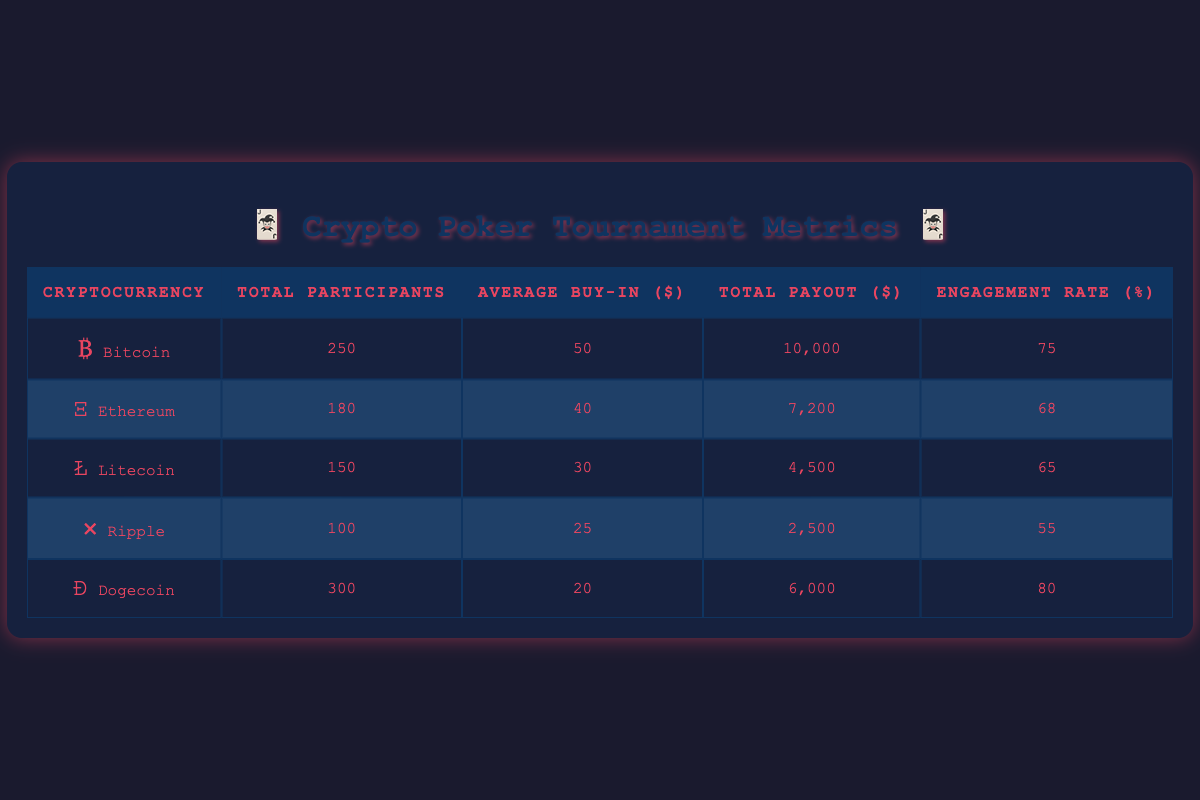What is the total payout for Dogecoin tournaments? In the table, the row for Dogecoin indicates that the total payout is $6000. This value is retrieved directly from the table without the need for calculations.
Answer: 6000 How many participants were there in Litecoin tournaments? The corresponding row for Litecoin indicates that there were 150 participants. This value is also directly retrieved from the table.
Answer: 150 Which cryptocurrency had the highest engagement rate? By examining the "Engagement Rate (%)" column, we find that Dogecoin has the highest engagement rate of 80%. This is the maximum value in that column.
Answer: Dogecoin What is the average buy-in for all tournaments combined? First, we sum the Average Buy-in amounts: (50 + 40 + 30 + 25 + 20) = 165. Then, we divide by the number of cryptocurrencies (5) to find the average: 165 / 5 = 33.
Answer: 33 Is the engagement rate for Ethereum greater than or equal to 70%? Looking at the engagement rate for Ethereum, which is 68%, we determine that it is not greater than or equal to 70%. Therefore, the answer is no.
Answer: No How much total payout was made across all poker tournaments? We sum up the total payouts for each cryptocurrency: (10000 + 7200 + 4500 + 2500 + 6000) = 32000. This gives us the total payout across all tournaments.
Answer: 32000 What is the difference in total participants between Bitcoin and Ripple tournaments? Bitcoin had 250 participants and Ripple had 100 participants. The difference is calculated as 250 - 100 = 150.
Answer: 150 Which cryptocurrency has the lowest average buy-in? By examining the "Average Buy-in ($)" column, we see that Dogecoin has the lowest average buy-in at $20, compared to others.
Answer: Dogecoin If we consider Bitcoin and Ethereum together, what is their combined total payout? The total payout for Bitcoin is $10000 and for Ethereum is $7200. We add these amounts: 10000 + 7200 = 17200, which gives us the combined total payout.
Answer: 17200 